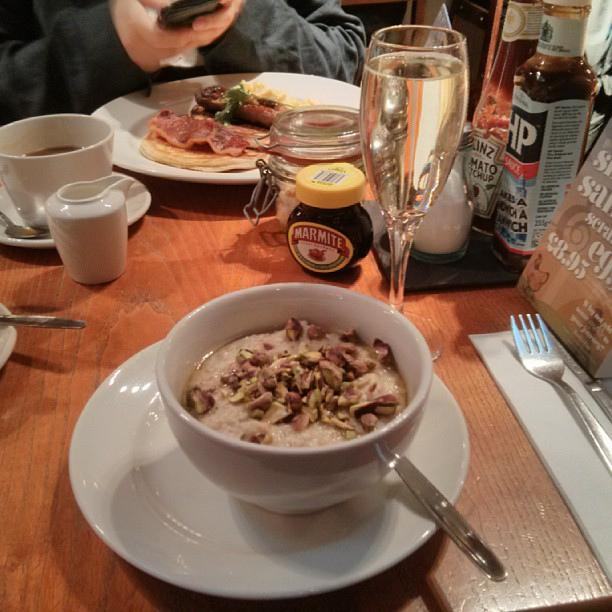The person that invented the item with the yellow lid was from what country?

Choices:
A) sweden
B) russia
C) thailand
D) germany germany 